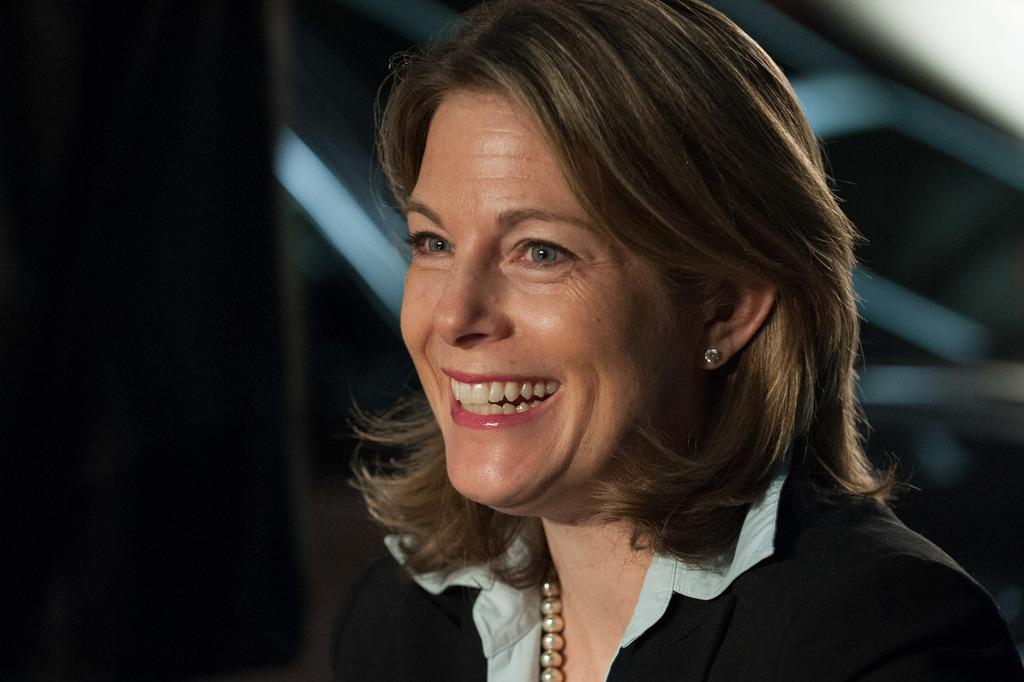Who is the main subject in the image? There is a lady in the center of the image. What is the lady doing in the image? The lady is smiling. What can be observed about the background of the image? The background of the image is dark. How many pictures are hanging on the wall in the room depicted in the image? There is no room or wall with pictures present in the image; it only features a lady in the center. 